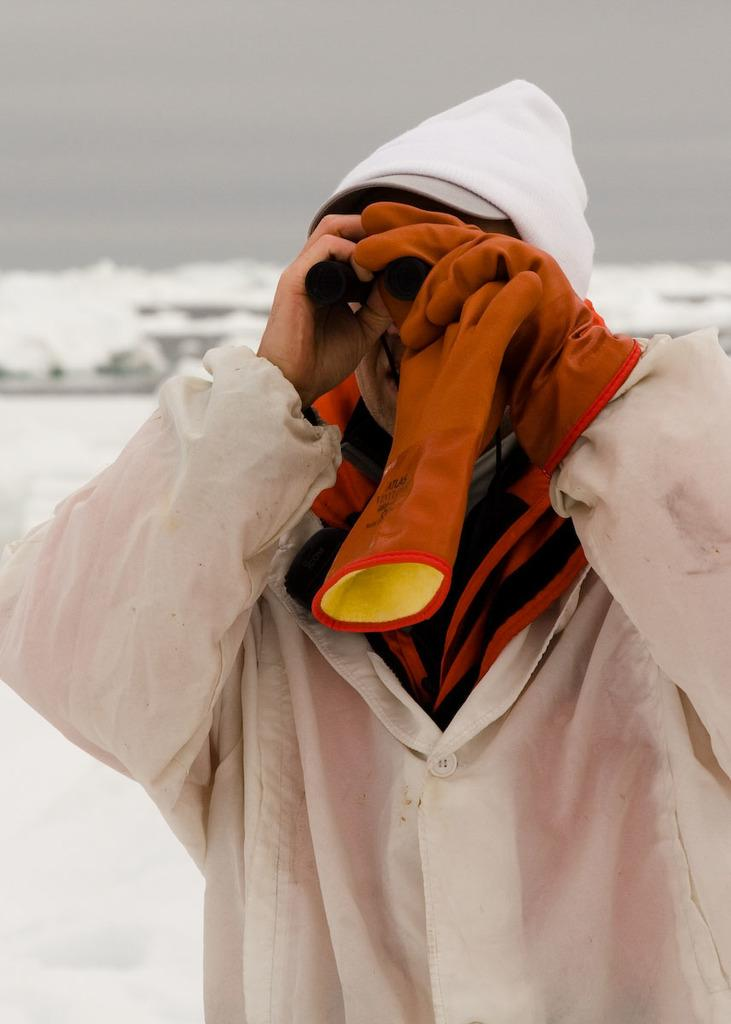What is the main subject of the image? There is a person in the image. What is the person wearing? The person is wearing a white coat. What is the person holding in the image? The person is holding binoculars. What can be seen in the background of the image? The background appears to have snow. What is visible at the top of the image? The sky is visible at the top of the image. What type of stream can be seen flowing through the person's coat in the image? There is no stream visible in the image, and the person's coat is not wet or damaged in any way. 